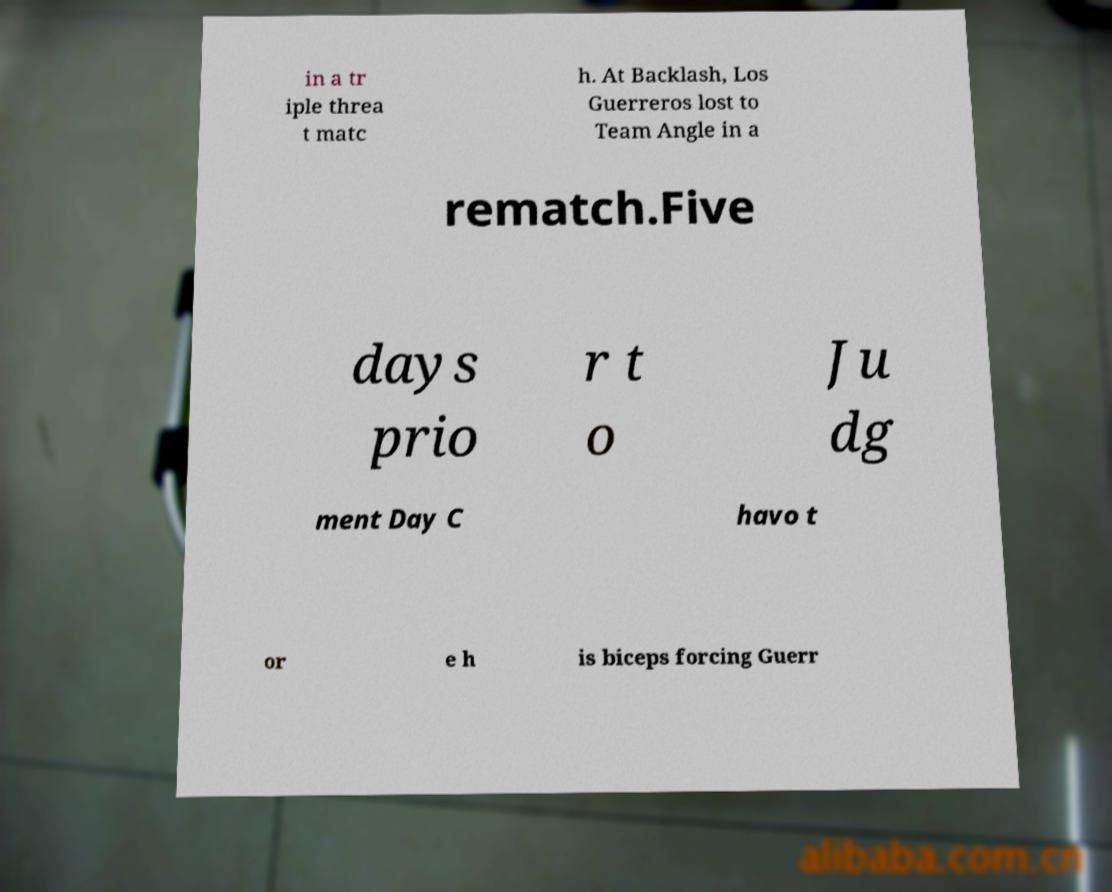Could you extract and type out the text from this image? in a tr iple threa t matc h. At Backlash, Los Guerreros lost to Team Angle in a rematch.Five days prio r t o Ju dg ment Day C havo t or e h is biceps forcing Guerr 